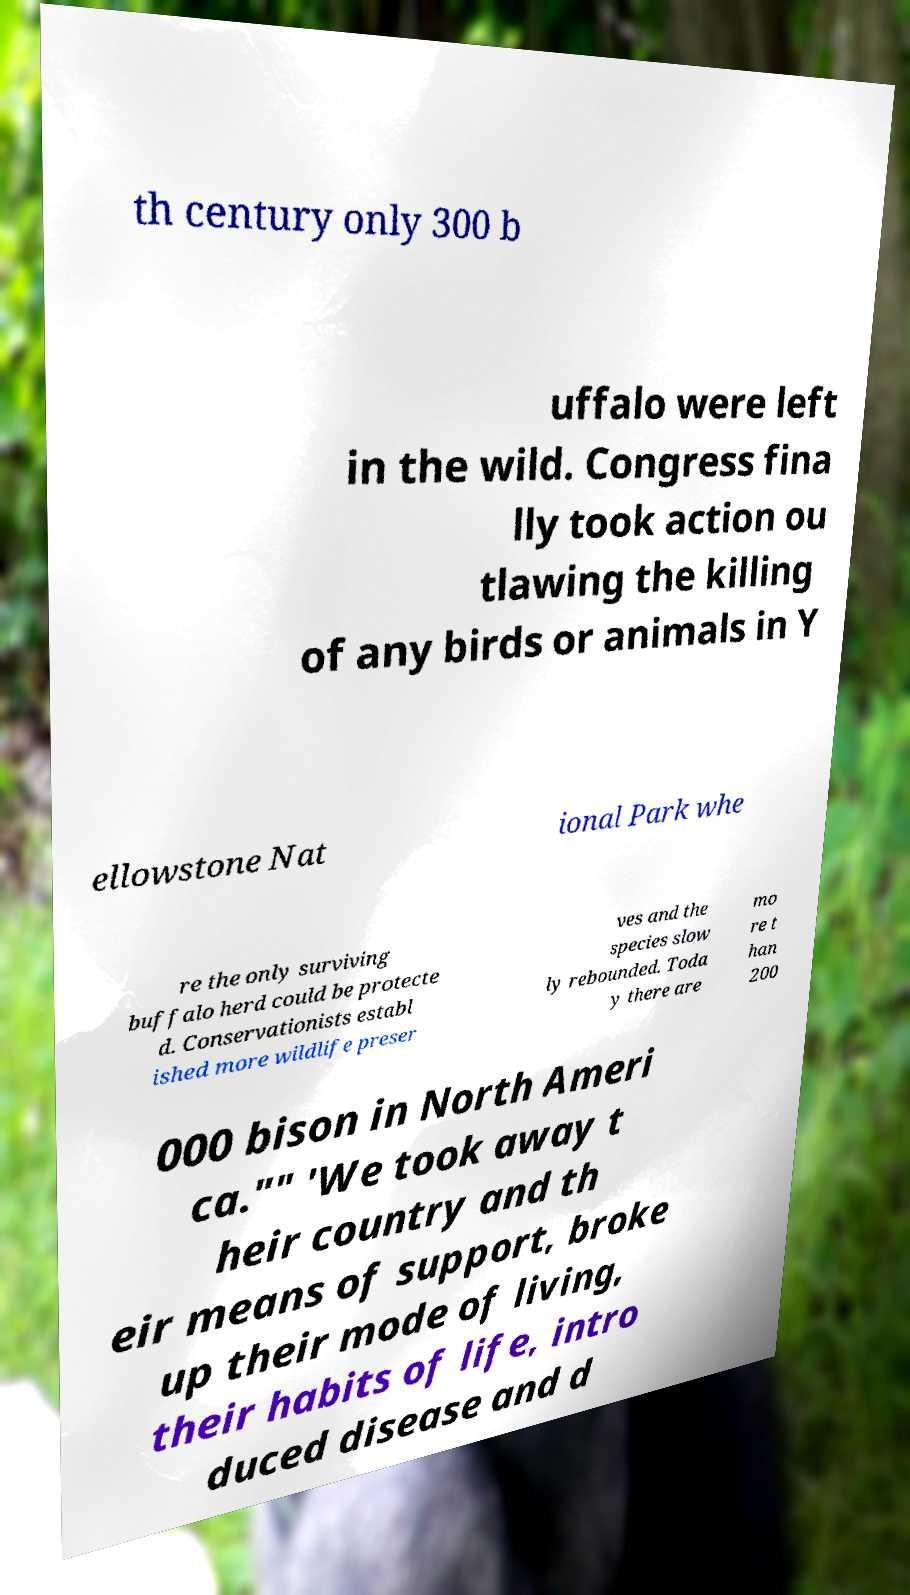Can you read and provide the text displayed in the image?This photo seems to have some interesting text. Can you extract and type it out for me? th century only 300 b uffalo were left in the wild. Congress fina lly took action ou tlawing the killing of any birds or animals in Y ellowstone Nat ional Park whe re the only surviving buffalo herd could be protecte d. Conservationists establ ished more wildlife preser ves and the species slow ly rebounded. Toda y there are mo re t han 200 000 bison in North Ameri ca."" 'We took away t heir country and th eir means of support, broke up their mode of living, their habits of life, intro duced disease and d 